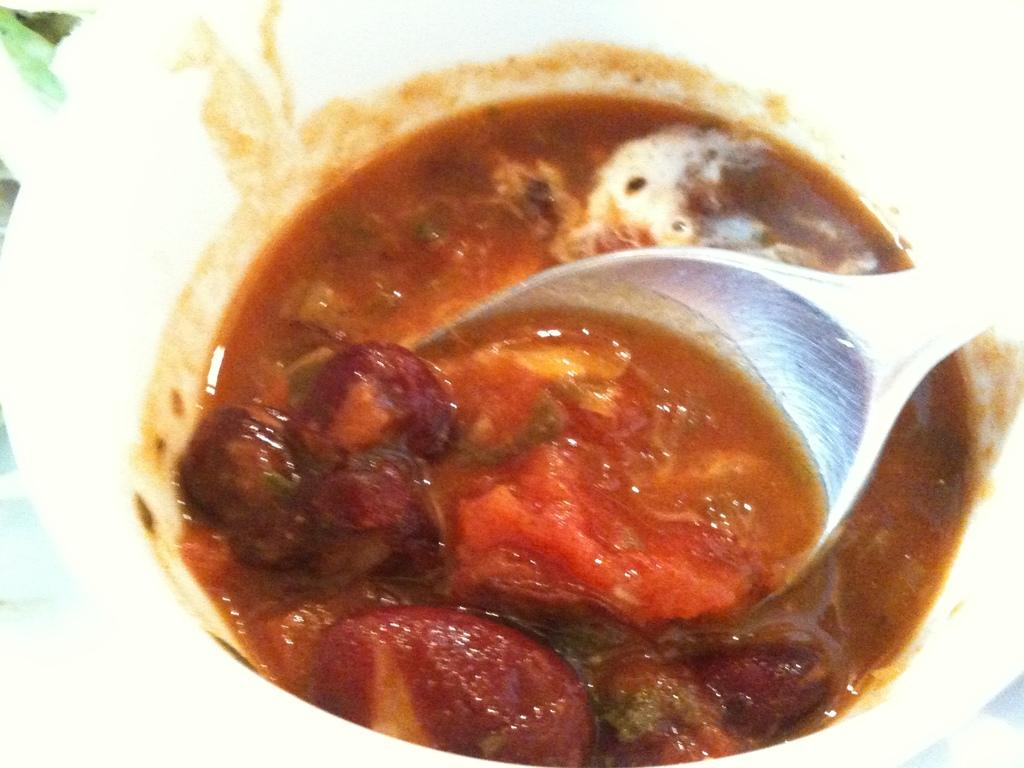What is the main object in the image? There is an object that looks like a bowl in the image. What is inside the bowl? There are food items in the bowl. What utensil is present in the bowl? There is a spoon in the bowl. Where is the giraffe hiding in the image? There is no giraffe present in the image. What type of nail can be seen in the image? There is no nail present in the image. 